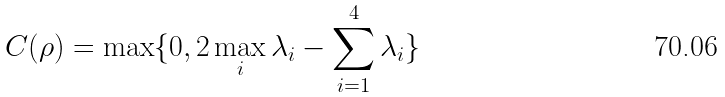Convert formula to latex. <formula><loc_0><loc_0><loc_500><loc_500>C ( { \rho } ) = \max \{ 0 , 2 \max _ { i } \lambda _ { i } - \sum _ { i = 1 } ^ { 4 } \lambda _ { i } \}</formula> 